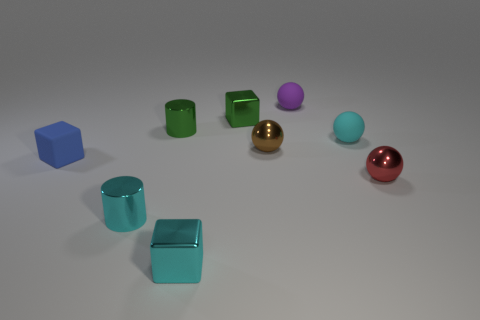Can you tell me which objects are spheres? Certainly, there are three spherical objects in the image. One sphere has a reflective gold finish, another has a reflective silver finish, and the third has a matte pink color. 